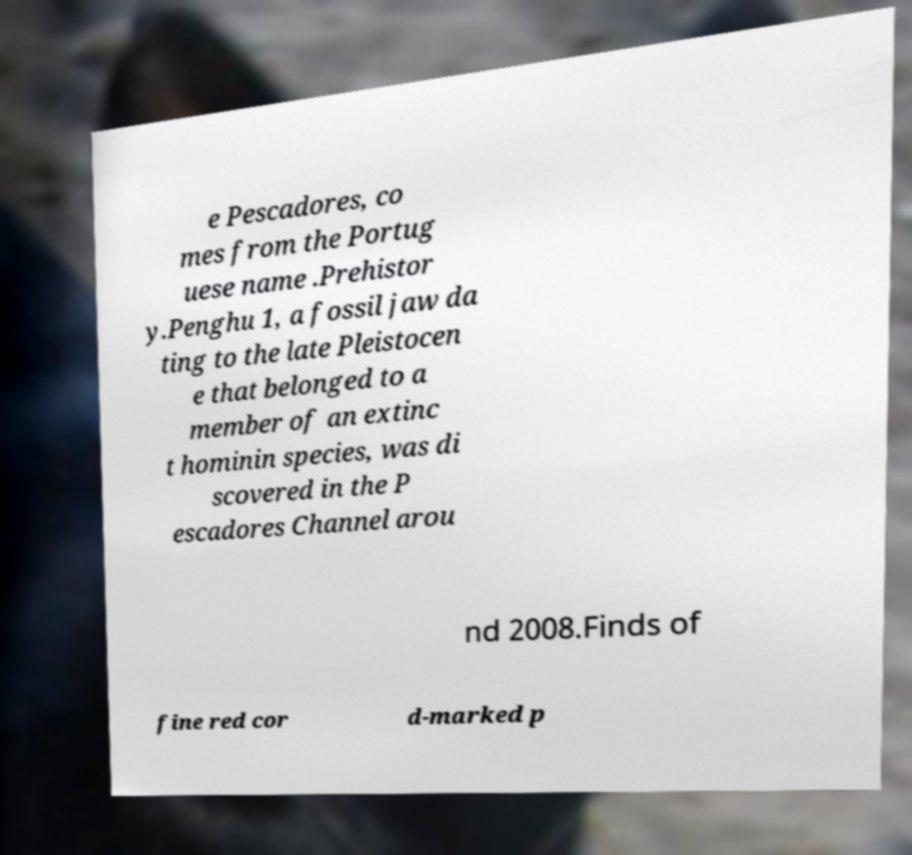Please identify and transcribe the text found in this image. e Pescadores, co mes from the Portug uese name .Prehistor y.Penghu 1, a fossil jaw da ting to the late Pleistocen e that belonged to a member of an extinc t hominin species, was di scovered in the P escadores Channel arou nd 2008.Finds of fine red cor d-marked p 